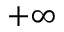<formula> <loc_0><loc_0><loc_500><loc_500>+ \infty</formula> 